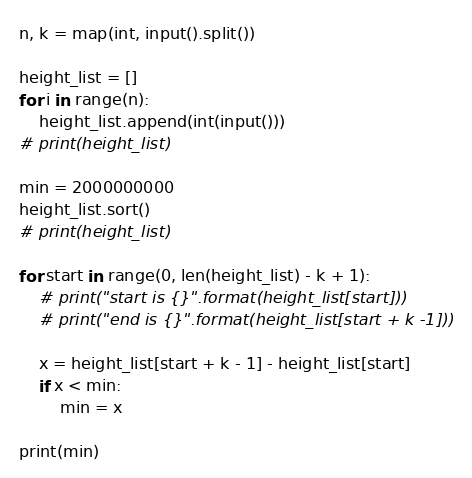<code> <loc_0><loc_0><loc_500><loc_500><_Python_>n, k = map(int, input().split())

height_list = []
for i in range(n):
    height_list.append(int(input()))
# print(height_list)

min = 2000000000
height_list.sort()
# print(height_list)

for start in range(0, len(height_list) - k + 1):
    # print("start is {}".format(height_list[start]))
    # print("end is {}".format(height_list[start + k -1]))

    x = height_list[start + k - 1] - height_list[start]
    if x < min:
        min = x

print(min)</code> 